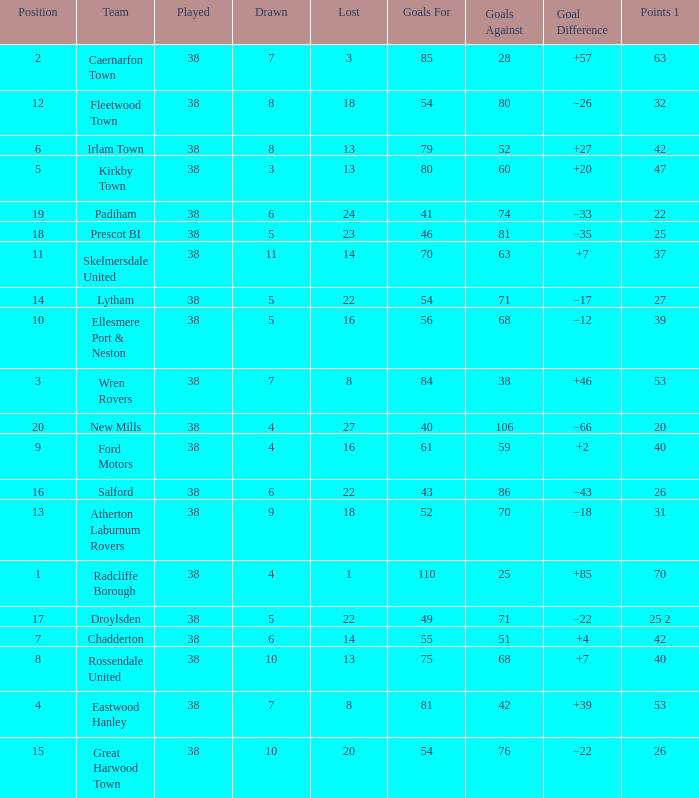Which Played has a Drawn of 4, and a Position of 9, and Goals Against larger than 59? None. 